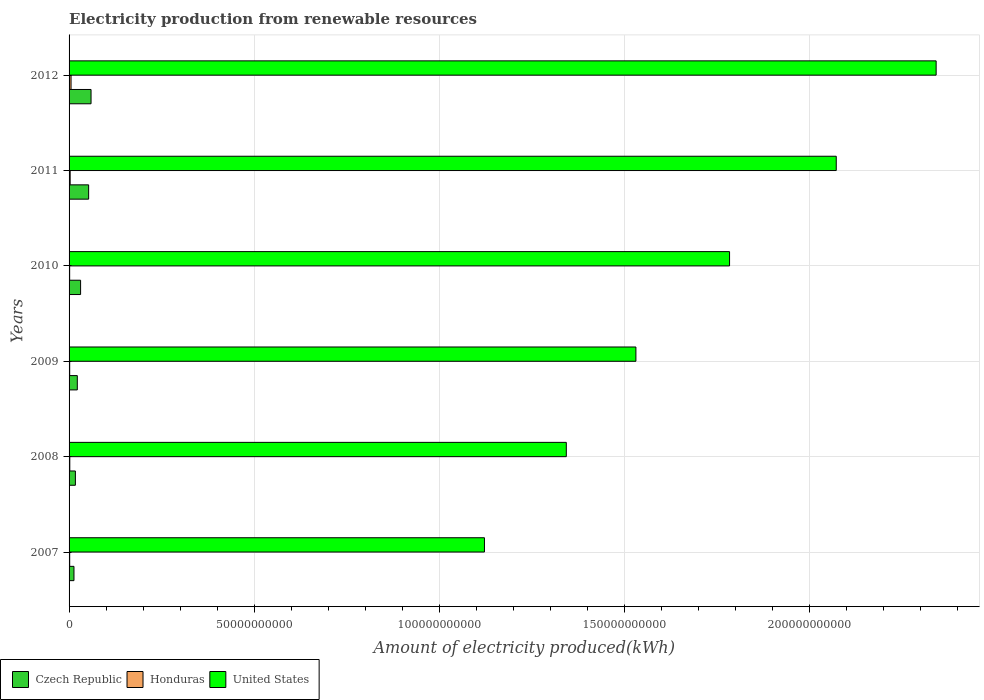How many different coloured bars are there?
Ensure brevity in your answer.  3. Are the number of bars per tick equal to the number of legend labels?
Give a very brief answer. Yes. How many bars are there on the 3rd tick from the top?
Provide a succinct answer. 3. How many bars are there on the 4th tick from the bottom?
Your answer should be very brief. 3. What is the label of the 3rd group of bars from the top?
Give a very brief answer. 2010. What is the amount of electricity produced in Czech Republic in 2010?
Offer a terse response. 3.11e+09. Across all years, what is the maximum amount of electricity produced in United States?
Keep it short and to the point. 2.34e+11. Across all years, what is the minimum amount of electricity produced in United States?
Make the answer very short. 1.12e+11. In which year was the amount of electricity produced in Czech Republic minimum?
Keep it short and to the point. 2007. What is the total amount of electricity produced in United States in the graph?
Give a very brief answer. 1.02e+12. What is the difference between the amount of electricity produced in United States in 2007 and that in 2009?
Provide a succinct answer. -4.09e+1. What is the difference between the amount of electricity produced in Czech Republic in 2011 and the amount of electricity produced in Honduras in 2008?
Provide a short and direct response. 5.09e+09. What is the average amount of electricity produced in United States per year?
Offer a very short reply. 1.70e+11. In the year 2011, what is the difference between the amount of electricity produced in Czech Republic and amount of electricity produced in United States?
Offer a terse response. -2.02e+11. What is the ratio of the amount of electricity produced in Czech Republic in 2009 to that in 2012?
Provide a succinct answer. 0.37. Is the difference between the amount of electricity produced in Czech Republic in 2007 and 2009 greater than the difference between the amount of electricity produced in United States in 2007 and 2009?
Your answer should be very brief. Yes. What is the difference between the highest and the second highest amount of electricity produced in United States?
Your answer should be compact. 2.70e+1. What is the difference between the highest and the lowest amount of electricity produced in United States?
Offer a terse response. 1.22e+11. In how many years, is the amount of electricity produced in Honduras greater than the average amount of electricity produced in Honduras taken over all years?
Your answer should be compact. 2. What does the 1st bar from the top in 2007 represents?
Give a very brief answer. United States. What does the 3rd bar from the bottom in 2012 represents?
Offer a terse response. United States. Is it the case that in every year, the sum of the amount of electricity produced in Czech Republic and amount of electricity produced in United States is greater than the amount of electricity produced in Honduras?
Give a very brief answer. Yes. Are all the bars in the graph horizontal?
Offer a terse response. Yes. Where does the legend appear in the graph?
Ensure brevity in your answer.  Bottom left. What is the title of the graph?
Make the answer very short. Electricity production from renewable resources. What is the label or title of the X-axis?
Keep it short and to the point. Amount of electricity produced(kWh). What is the label or title of the Y-axis?
Your response must be concise. Years. What is the Amount of electricity produced(kWh) of Czech Republic in 2007?
Ensure brevity in your answer.  1.32e+09. What is the Amount of electricity produced(kWh) of Honduras in 2007?
Provide a succinct answer. 1.68e+08. What is the Amount of electricity produced(kWh) in United States in 2007?
Offer a terse response. 1.12e+11. What is the Amount of electricity produced(kWh) in Czech Republic in 2008?
Your response must be concise. 1.71e+09. What is the Amount of electricity produced(kWh) in Honduras in 2008?
Your answer should be very brief. 1.97e+08. What is the Amount of electricity produced(kWh) of United States in 2008?
Provide a short and direct response. 1.34e+11. What is the Amount of electricity produced(kWh) of Czech Republic in 2009?
Make the answer very short. 2.22e+09. What is the Amount of electricity produced(kWh) of Honduras in 2009?
Give a very brief answer. 1.68e+08. What is the Amount of electricity produced(kWh) of United States in 2009?
Your answer should be very brief. 1.53e+11. What is the Amount of electricity produced(kWh) in Czech Republic in 2010?
Your answer should be very brief. 3.11e+09. What is the Amount of electricity produced(kWh) of Honduras in 2010?
Keep it short and to the point. 1.60e+08. What is the Amount of electricity produced(kWh) in United States in 2010?
Offer a terse response. 1.78e+11. What is the Amount of electricity produced(kWh) of Czech Republic in 2011?
Provide a short and direct response. 5.28e+09. What is the Amount of electricity produced(kWh) of Honduras in 2011?
Your answer should be very brief. 2.95e+08. What is the Amount of electricity produced(kWh) in United States in 2011?
Your answer should be compact. 2.07e+11. What is the Amount of electricity produced(kWh) of Czech Republic in 2012?
Offer a terse response. 5.94e+09. What is the Amount of electricity produced(kWh) in Honduras in 2012?
Provide a succinct answer. 5.34e+08. What is the Amount of electricity produced(kWh) in United States in 2012?
Ensure brevity in your answer.  2.34e+11. Across all years, what is the maximum Amount of electricity produced(kWh) in Czech Republic?
Ensure brevity in your answer.  5.94e+09. Across all years, what is the maximum Amount of electricity produced(kWh) of Honduras?
Make the answer very short. 5.34e+08. Across all years, what is the maximum Amount of electricity produced(kWh) in United States?
Make the answer very short. 2.34e+11. Across all years, what is the minimum Amount of electricity produced(kWh) of Czech Republic?
Your response must be concise. 1.32e+09. Across all years, what is the minimum Amount of electricity produced(kWh) of Honduras?
Offer a very short reply. 1.60e+08. Across all years, what is the minimum Amount of electricity produced(kWh) in United States?
Offer a terse response. 1.12e+11. What is the total Amount of electricity produced(kWh) in Czech Republic in the graph?
Your answer should be very brief. 1.96e+1. What is the total Amount of electricity produced(kWh) of Honduras in the graph?
Your answer should be very brief. 1.52e+09. What is the total Amount of electricity produced(kWh) in United States in the graph?
Keep it short and to the point. 1.02e+12. What is the difference between the Amount of electricity produced(kWh) in Czech Republic in 2007 and that in 2008?
Your answer should be very brief. -3.86e+08. What is the difference between the Amount of electricity produced(kWh) of Honduras in 2007 and that in 2008?
Ensure brevity in your answer.  -2.90e+07. What is the difference between the Amount of electricity produced(kWh) of United States in 2007 and that in 2008?
Give a very brief answer. -2.21e+1. What is the difference between the Amount of electricity produced(kWh) in Czech Republic in 2007 and that in 2009?
Your response must be concise. -9.04e+08. What is the difference between the Amount of electricity produced(kWh) of Honduras in 2007 and that in 2009?
Provide a short and direct response. 0. What is the difference between the Amount of electricity produced(kWh) in United States in 2007 and that in 2009?
Offer a terse response. -4.09e+1. What is the difference between the Amount of electricity produced(kWh) in Czech Republic in 2007 and that in 2010?
Your answer should be compact. -1.79e+09. What is the difference between the Amount of electricity produced(kWh) in Honduras in 2007 and that in 2010?
Make the answer very short. 8.00e+06. What is the difference between the Amount of electricity produced(kWh) in United States in 2007 and that in 2010?
Your answer should be very brief. -6.62e+1. What is the difference between the Amount of electricity produced(kWh) of Czech Republic in 2007 and that in 2011?
Provide a succinct answer. -3.96e+09. What is the difference between the Amount of electricity produced(kWh) of Honduras in 2007 and that in 2011?
Make the answer very short. -1.27e+08. What is the difference between the Amount of electricity produced(kWh) of United States in 2007 and that in 2011?
Your answer should be very brief. -9.50e+1. What is the difference between the Amount of electricity produced(kWh) of Czech Republic in 2007 and that in 2012?
Ensure brevity in your answer.  -4.62e+09. What is the difference between the Amount of electricity produced(kWh) in Honduras in 2007 and that in 2012?
Provide a succinct answer. -3.66e+08. What is the difference between the Amount of electricity produced(kWh) in United States in 2007 and that in 2012?
Provide a short and direct response. -1.22e+11. What is the difference between the Amount of electricity produced(kWh) of Czech Republic in 2008 and that in 2009?
Provide a short and direct response. -5.18e+08. What is the difference between the Amount of electricity produced(kWh) in Honduras in 2008 and that in 2009?
Offer a very short reply. 2.90e+07. What is the difference between the Amount of electricity produced(kWh) in United States in 2008 and that in 2009?
Provide a short and direct response. -1.88e+1. What is the difference between the Amount of electricity produced(kWh) of Czech Republic in 2008 and that in 2010?
Give a very brief answer. -1.41e+09. What is the difference between the Amount of electricity produced(kWh) of Honduras in 2008 and that in 2010?
Your response must be concise. 3.70e+07. What is the difference between the Amount of electricity produced(kWh) of United States in 2008 and that in 2010?
Your response must be concise. -4.41e+1. What is the difference between the Amount of electricity produced(kWh) of Czech Republic in 2008 and that in 2011?
Offer a terse response. -3.58e+09. What is the difference between the Amount of electricity produced(kWh) of Honduras in 2008 and that in 2011?
Your answer should be compact. -9.80e+07. What is the difference between the Amount of electricity produced(kWh) of United States in 2008 and that in 2011?
Provide a short and direct response. -7.29e+1. What is the difference between the Amount of electricity produced(kWh) in Czech Republic in 2008 and that in 2012?
Provide a succinct answer. -4.23e+09. What is the difference between the Amount of electricity produced(kWh) in Honduras in 2008 and that in 2012?
Offer a very short reply. -3.37e+08. What is the difference between the Amount of electricity produced(kWh) of United States in 2008 and that in 2012?
Your response must be concise. -9.99e+1. What is the difference between the Amount of electricity produced(kWh) of Czech Republic in 2009 and that in 2010?
Provide a succinct answer. -8.88e+08. What is the difference between the Amount of electricity produced(kWh) in Honduras in 2009 and that in 2010?
Keep it short and to the point. 8.00e+06. What is the difference between the Amount of electricity produced(kWh) of United States in 2009 and that in 2010?
Your answer should be very brief. -2.53e+1. What is the difference between the Amount of electricity produced(kWh) in Czech Republic in 2009 and that in 2011?
Make the answer very short. -3.06e+09. What is the difference between the Amount of electricity produced(kWh) of Honduras in 2009 and that in 2011?
Make the answer very short. -1.27e+08. What is the difference between the Amount of electricity produced(kWh) of United States in 2009 and that in 2011?
Make the answer very short. -5.41e+1. What is the difference between the Amount of electricity produced(kWh) of Czech Republic in 2009 and that in 2012?
Your response must be concise. -3.71e+09. What is the difference between the Amount of electricity produced(kWh) of Honduras in 2009 and that in 2012?
Give a very brief answer. -3.66e+08. What is the difference between the Amount of electricity produced(kWh) of United States in 2009 and that in 2012?
Offer a terse response. -8.11e+1. What is the difference between the Amount of electricity produced(kWh) of Czech Republic in 2010 and that in 2011?
Keep it short and to the point. -2.17e+09. What is the difference between the Amount of electricity produced(kWh) of Honduras in 2010 and that in 2011?
Offer a terse response. -1.35e+08. What is the difference between the Amount of electricity produced(kWh) of United States in 2010 and that in 2011?
Your response must be concise. -2.88e+1. What is the difference between the Amount of electricity produced(kWh) in Czech Republic in 2010 and that in 2012?
Provide a succinct answer. -2.82e+09. What is the difference between the Amount of electricity produced(kWh) of Honduras in 2010 and that in 2012?
Keep it short and to the point. -3.74e+08. What is the difference between the Amount of electricity produced(kWh) of United States in 2010 and that in 2012?
Make the answer very short. -5.58e+1. What is the difference between the Amount of electricity produced(kWh) in Czech Republic in 2011 and that in 2012?
Make the answer very short. -6.51e+08. What is the difference between the Amount of electricity produced(kWh) of Honduras in 2011 and that in 2012?
Keep it short and to the point. -2.39e+08. What is the difference between the Amount of electricity produced(kWh) in United States in 2011 and that in 2012?
Give a very brief answer. -2.70e+1. What is the difference between the Amount of electricity produced(kWh) of Czech Republic in 2007 and the Amount of electricity produced(kWh) of Honduras in 2008?
Your answer should be very brief. 1.12e+09. What is the difference between the Amount of electricity produced(kWh) of Czech Republic in 2007 and the Amount of electricity produced(kWh) of United States in 2008?
Your answer should be compact. -1.33e+11. What is the difference between the Amount of electricity produced(kWh) of Honduras in 2007 and the Amount of electricity produced(kWh) of United States in 2008?
Offer a very short reply. -1.34e+11. What is the difference between the Amount of electricity produced(kWh) in Czech Republic in 2007 and the Amount of electricity produced(kWh) in Honduras in 2009?
Provide a short and direct response. 1.15e+09. What is the difference between the Amount of electricity produced(kWh) in Czech Republic in 2007 and the Amount of electricity produced(kWh) in United States in 2009?
Your answer should be compact. -1.52e+11. What is the difference between the Amount of electricity produced(kWh) in Honduras in 2007 and the Amount of electricity produced(kWh) in United States in 2009?
Your answer should be compact. -1.53e+11. What is the difference between the Amount of electricity produced(kWh) of Czech Republic in 2007 and the Amount of electricity produced(kWh) of Honduras in 2010?
Your answer should be very brief. 1.16e+09. What is the difference between the Amount of electricity produced(kWh) in Czech Republic in 2007 and the Amount of electricity produced(kWh) in United States in 2010?
Make the answer very short. -1.77e+11. What is the difference between the Amount of electricity produced(kWh) of Honduras in 2007 and the Amount of electricity produced(kWh) of United States in 2010?
Offer a very short reply. -1.78e+11. What is the difference between the Amount of electricity produced(kWh) in Czech Republic in 2007 and the Amount of electricity produced(kWh) in Honduras in 2011?
Your response must be concise. 1.03e+09. What is the difference between the Amount of electricity produced(kWh) in Czech Republic in 2007 and the Amount of electricity produced(kWh) in United States in 2011?
Provide a succinct answer. -2.06e+11. What is the difference between the Amount of electricity produced(kWh) of Honduras in 2007 and the Amount of electricity produced(kWh) of United States in 2011?
Your answer should be compact. -2.07e+11. What is the difference between the Amount of electricity produced(kWh) of Czech Republic in 2007 and the Amount of electricity produced(kWh) of Honduras in 2012?
Give a very brief answer. 7.87e+08. What is the difference between the Amount of electricity produced(kWh) of Czech Republic in 2007 and the Amount of electricity produced(kWh) of United States in 2012?
Provide a short and direct response. -2.33e+11. What is the difference between the Amount of electricity produced(kWh) in Honduras in 2007 and the Amount of electricity produced(kWh) in United States in 2012?
Your answer should be very brief. -2.34e+11. What is the difference between the Amount of electricity produced(kWh) in Czech Republic in 2008 and the Amount of electricity produced(kWh) in Honduras in 2009?
Ensure brevity in your answer.  1.54e+09. What is the difference between the Amount of electricity produced(kWh) in Czech Republic in 2008 and the Amount of electricity produced(kWh) in United States in 2009?
Your response must be concise. -1.51e+11. What is the difference between the Amount of electricity produced(kWh) of Honduras in 2008 and the Amount of electricity produced(kWh) of United States in 2009?
Offer a very short reply. -1.53e+11. What is the difference between the Amount of electricity produced(kWh) of Czech Republic in 2008 and the Amount of electricity produced(kWh) of Honduras in 2010?
Your answer should be very brief. 1.55e+09. What is the difference between the Amount of electricity produced(kWh) in Czech Republic in 2008 and the Amount of electricity produced(kWh) in United States in 2010?
Your answer should be compact. -1.77e+11. What is the difference between the Amount of electricity produced(kWh) of Honduras in 2008 and the Amount of electricity produced(kWh) of United States in 2010?
Provide a short and direct response. -1.78e+11. What is the difference between the Amount of electricity produced(kWh) of Czech Republic in 2008 and the Amount of electricity produced(kWh) of Honduras in 2011?
Provide a short and direct response. 1.41e+09. What is the difference between the Amount of electricity produced(kWh) of Czech Republic in 2008 and the Amount of electricity produced(kWh) of United States in 2011?
Provide a short and direct response. -2.06e+11. What is the difference between the Amount of electricity produced(kWh) of Honduras in 2008 and the Amount of electricity produced(kWh) of United States in 2011?
Provide a short and direct response. -2.07e+11. What is the difference between the Amount of electricity produced(kWh) of Czech Republic in 2008 and the Amount of electricity produced(kWh) of Honduras in 2012?
Your answer should be very brief. 1.17e+09. What is the difference between the Amount of electricity produced(kWh) of Czech Republic in 2008 and the Amount of electricity produced(kWh) of United States in 2012?
Your answer should be compact. -2.32e+11. What is the difference between the Amount of electricity produced(kWh) in Honduras in 2008 and the Amount of electricity produced(kWh) in United States in 2012?
Your answer should be compact. -2.34e+11. What is the difference between the Amount of electricity produced(kWh) in Czech Republic in 2009 and the Amount of electricity produced(kWh) in Honduras in 2010?
Keep it short and to the point. 2.06e+09. What is the difference between the Amount of electricity produced(kWh) of Czech Republic in 2009 and the Amount of electricity produced(kWh) of United States in 2010?
Your response must be concise. -1.76e+11. What is the difference between the Amount of electricity produced(kWh) of Honduras in 2009 and the Amount of electricity produced(kWh) of United States in 2010?
Keep it short and to the point. -1.78e+11. What is the difference between the Amount of electricity produced(kWh) of Czech Republic in 2009 and the Amount of electricity produced(kWh) of Honduras in 2011?
Keep it short and to the point. 1.93e+09. What is the difference between the Amount of electricity produced(kWh) of Czech Republic in 2009 and the Amount of electricity produced(kWh) of United States in 2011?
Make the answer very short. -2.05e+11. What is the difference between the Amount of electricity produced(kWh) in Honduras in 2009 and the Amount of electricity produced(kWh) in United States in 2011?
Provide a succinct answer. -2.07e+11. What is the difference between the Amount of electricity produced(kWh) of Czech Republic in 2009 and the Amount of electricity produced(kWh) of Honduras in 2012?
Your response must be concise. 1.69e+09. What is the difference between the Amount of electricity produced(kWh) of Czech Republic in 2009 and the Amount of electricity produced(kWh) of United States in 2012?
Keep it short and to the point. -2.32e+11. What is the difference between the Amount of electricity produced(kWh) of Honduras in 2009 and the Amount of electricity produced(kWh) of United States in 2012?
Your answer should be compact. -2.34e+11. What is the difference between the Amount of electricity produced(kWh) of Czech Republic in 2010 and the Amount of electricity produced(kWh) of Honduras in 2011?
Give a very brief answer. 2.82e+09. What is the difference between the Amount of electricity produced(kWh) of Czech Republic in 2010 and the Amount of electricity produced(kWh) of United States in 2011?
Keep it short and to the point. -2.04e+11. What is the difference between the Amount of electricity produced(kWh) of Honduras in 2010 and the Amount of electricity produced(kWh) of United States in 2011?
Offer a very short reply. -2.07e+11. What is the difference between the Amount of electricity produced(kWh) of Czech Republic in 2010 and the Amount of electricity produced(kWh) of Honduras in 2012?
Keep it short and to the point. 2.58e+09. What is the difference between the Amount of electricity produced(kWh) of Czech Republic in 2010 and the Amount of electricity produced(kWh) of United States in 2012?
Give a very brief answer. -2.31e+11. What is the difference between the Amount of electricity produced(kWh) of Honduras in 2010 and the Amount of electricity produced(kWh) of United States in 2012?
Your answer should be very brief. -2.34e+11. What is the difference between the Amount of electricity produced(kWh) in Czech Republic in 2011 and the Amount of electricity produced(kWh) in Honduras in 2012?
Provide a short and direct response. 4.75e+09. What is the difference between the Amount of electricity produced(kWh) of Czech Republic in 2011 and the Amount of electricity produced(kWh) of United States in 2012?
Offer a terse response. -2.29e+11. What is the difference between the Amount of electricity produced(kWh) of Honduras in 2011 and the Amount of electricity produced(kWh) of United States in 2012?
Offer a terse response. -2.34e+11. What is the average Amount of electricity produced(kWh) in Czech Republic per year?
Provide a succinct answer. 3.26e+09. What is the average Amount of electricity produced(kWh) in Honduras per year?
Offer a very short reply. 2.54e+08. What is the average Amount of electricity produced(kWh) in United States per year?
Offer a terse response. 1.70e+11. In the year 2007, what is the difference between the Amount of electricity produced(kWh) of Czech Republic and Amount of electricity produced(kWh) of Honduras?
Your response must be concise. 1.15e+09. In the year 2007, what is the difference between the Amount of electricity produced(kWh) of Czech Republic and Amount of electricity produced(kWh) of United States?
Your answer should be compact. -1.11e+11. In the year 2007, what is the difference between the Amount of electricity produced(kWh) of Honduras and Amount of electricity produced(kWh) of United States?
Your response must be concise. -1.12e+11. In the year 2008, what is the difference between the Amount of electricity produced(kWh) in Czech Republic and Amount of electricity produced(kWh) in Honduras?
Offer a very short reply. 1.51e+09. In the year 2008, what is the difference between the Amount of electricity produced(kWh) in Czech Republic and Amount of electricity produced(kWh) in United States?
Offer a terse response. -1.33e+11. In the year 2008, what is the difference between the Amount of electricity produced(kWh) of Honduras and Amount of electricity produced(kWh) of United States?
Keep it short and to the point. -1.34e+11. In the year 2009, what is the difference between the Amount of electricity produced(kWh) of Czech Republic and Amount of electricity produced(kWh) of Honduras?
Your answer should be compact. 2.06e+09. In the year 2009, what is the difference between the Amount of electricity produced(kWh) of Czech Republic and Amount of electricity produced(kWh) of United States?
Keep it short and to the point. -1.51e+11. In the year 2009, what is the difference between the Amount of electricity produced(kWh) of Honduras and Amount of electricity produced(kWh) of United States?
Ensure brevity in your answer.  -1.53e+11. In the year 2010, what is the difference between the Amount of electricity produced(kWh) of Czech Republic and Amount of electricity produced(kWh) of Honduras?
Your answer should be compact. 2.95e+09. In the year 2010, what is the difference between the Amount of electricity produced(kWh) of Czech Republic and Amount of electricity produced(kWh) of United States?
Your answer should be very brief. -1.75e+11. In the year 2010, what is the difference between the Amount of electricity produced(kWh) in Honduras and Amount of electricity produced(kWh) in United States?
Provide a short and direct response. -1.78e+11. In the year 2011, what is the difference between the Amount of electricity produced(kWh) in Czech Republic and Amount of electricity produced(kWh) in Honduras?
Make the answer very short. 4.99e+09. In the year 2011, what is the difference between the Amount of electricity produced(kWh) of Czech Republic and Amount of electricity produced(kWh) of United States?
Offer a very short reply. -2.02e+11. In the year 2011, what is the difference between the Amount of electricity produced(kWh) of Honduras and Amount of electricity produced(kWh) of United States?
Make the answer very short. -2.07e+11. In the year 2012, what is the difference between the Amount of electricity produced(kWh) of Czech Republic and Amount of electricity produced(kWh) of Honduras?
Keep it short and to the point. 5.40e+09. In the year 2012, what is the difference between the Amount of electricity produced(kWh) in Czech Republic and Amount of electricity produced(kWh) in United States?
Ensure brevity in your answer.  -2.28e+11. In the year 2012, what is the difference between the Amount of electricity produced(kWh) in Honduras and Amount of electricity produced(kWh) in United States?
Provide a short and direct response. -2.34e+11. What is the ratio of the Amount of electricity produced(kWh) of Czech Republic in 2007 to that in 2008?
Provide a short and direct response. 0.77. What is the ratio of the Amount of electricity produced(kWh) of Honduras in 2007 to that in 2008?
Make the answer very short. 0.85. What is the ratio of the Amount of electricity produced(kWh) of United States in 2007 to that in 2008?
Provide a short and direct response. 0.84. What is the ratio of the Amount of electricity produced(kWh) of Czech Republic in 2007 to that in 2009?
Offer a very short reply. 0.59. What is the ratio of the Amount of electricity produced(kWh) of United States in 2007 to that in 2009?
Provide a short and direct response. 0.73. What is the ratio of the Amount of electricity produced(kWh) in Czech Republic in 2007 to that in 2010?
Make the answer very short. 0.42. What is the ratio of the Amount of electricity produced(kWh) in United States in 2007 to that in 2010?
Make the answer very short. 0.63. What is the ratio of the Amount of electricity produced(kWh) of Czech Republic in 2007 to that in 2011?
Offer a very short reply. 0.25. What is the ratio of the Amount of electricity produced(kWh) of Honduras in 2007 to that in 2011?
Provide a short and direct response. 0.57. What is the ratio of the Amount of electricity produced(kWh) of United States in 2007 to that in 2011?
Provide a short and direct response. 0.54. What is the ratio of the Amount of electricity produced(kWh) of Czech Republic in 2007 to that in 2012?
Offer a terse response. 0.22. What is the ratio of the Amount of electricity produced(kWh) in Honduras in 2007 to that in 2012?
Offer a very short reply. 0.31. What is the ratio of the Amount of electricity produced(kWh) in United States in 2007 to that in 2012?
Offer a very short reply. 0.48. What is the ratio of the Amount of electricity produced(kWh) of Czech Republic in 2008 to that in 2009?
Provide a short and direct response. 0.77. What is the ratio of the Amount of electricity produced(kWh) of Honduras in 2008 to that in 2009?
Ensure brevity in your answer.  1.17. What is the ratio of the Amount of electricity produced(kWh) in United States in 2008 to that in 2009?
Your response must be concise. 0.88. What is the ratio of the Amount of electricity produced(kWh) of Czech Republic in 2008 to that in 2010?
Make the answer very short. 0.55. What is the ratio of the Amount of electricity produced(kWh) of Honduras in 2008 to that in 2010?
Provide a succinct answer. 1.23. What is the ratio of the Amount of electricity produced(kWh) in United States in 2008 to that in 2010?
Offer a terse response. 0.75. What is the ratio of the Amount of electricity produced(kWh) of Czech Republic in 2008 to that in 2011?
Ensure brevity in your answer.  0.32. What is the ratio of the Amount of electricity produced(kWh) of Honduras in 2008 to that in 2011?
Provide a succinct answer. 0.67. What is the ratio of the Amount of electricity produced(kWh) of United States in 2008 to that in 2011?
Provide a short and direct response. 0.65. What is the ratio of the Amount of electricity produced(kWh) in Czech Republic in 2008 to that in 2012?
Give a very brief answer. 0.29. What is the ratio of the Amount of electricity produced(kWh) of Honduras in 2008 to that in 2012?
Your response must be concise. 0.37. What is the ratio of the Amount of electricity produced(kWh) of United States in 2008 to that in 2012?
Provide a succinct answer. 0.57. What is the ratio of the Amount of electricity produced(kWh) of Czech Republic in 2009 to that in 2010?
Offer a terse response. 0.71. What is the ratio of the Amount of electricity produced(kWh) in United States in 2009 to that in 2010?
Offer a very short reply. 0.86. What is the ratio of the Amount of electricity produced(kWh) in Czech Republic in 2009 to that in 2011?
Give a very brief answer. 0.42. What is the ratio of the Amount of electricity produced(kWh) of Honduras in 2009 to that in 2011?
Give a very brief answer. 0.57. What is the ratio of the Amount of electricity produced(kWh) of United States in 2009 to that in 2011?
Your answer should be compact. 0.74. What is the ratio of the Amount of electricity produced(kWh) of Czech Republic in 2009 to that in 2012?
Offer a terse response. 0.37. What is the ratio of the Amount of electricity produced(kWh) of Honduras in 2009 to that in 2012?
Offer a terse response. 0.31. What is the ratio of the Amount of electricity produced(kWh) of United States in 2009 to that in 2012?
Provide a short and direct response. 0.65. What is the ratio of the Amount of electricity produced(kWh) of Czech Republic in 2010 to that in 2011?
Offer a very short reply. 0.59. What is the ratio of the Amount of electricity produced(kWh) in Honduras in 2010 to that in 2011?
Your answer should be compact. 0.54. What is the ratio of the Amount of electricity produced(kWh) of United States in 2010 to that in 2011?
Provide a short and direct response. 0.86. What is the ratio of the Amount of electricity produced(kWh) in Czech Republic in 2010 to that in 2012?
Provide a short and direct response. 0.52. What is the ratio of the Amount of electricity produced(kWh) of Honduras in 2010 to that in 2012?
Offer a very short reply. 0.3. What is the ratio of the Amount of electricity produced(kWh) of United States in 2010 to that in 2012?
Provide a succinct answer. 0.76. What is the ratio of the Amount of electricity produced(kWh) of Czech Republic in 2011 to that in 2012?
Your answer should be very brief. 0.89. What is the ratio of the Amount of electricity produced(kWh) of Honduras in 2011 to that in 2012?
Provide a short and direct response. 0.55. What is the ratio of the Amount of electricity produced(kWh) of United States in 2011 to that in 2012?
Make the answer very short. 0.88. What is the difference between the highest and the second highest Amount of electricity produced(kWh) in Czech Republic?
Your answer should be compact. 6.51e+08. What is the difference between the highest and the second highest Amount of electricity produced(kWh) in Honduras?
Ensure brevity in your answer.  2.39e+08. What is the difference between the highest and the second highest Amount of electricity produced(kWh) of United States?
Your answer should be compact. 2.70e+1. What is the difference between the highest and the lowest Amount of electricity produced(kWh) in Czech Republic?
Offer a terse response. 4.62e+09. What is the difference between the highest and the lowest Amount of electricity produced(kWh) in Honduras?
Ensure brevity in your answer.  3.74e+08. What is the difference between the highest and the lowest Amount of electricity produced(kWh) in United States?
Give a very brief answer. 1.22e+11. 